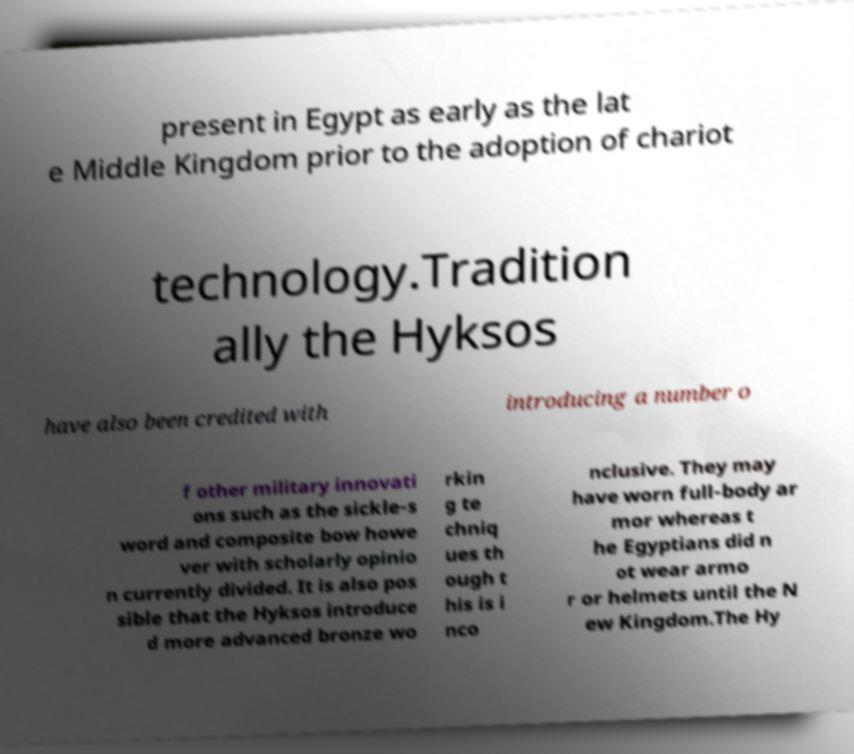I need the written content from this picture converted into text. Can you do that? present in Egypt as early as the lat e Middle Kingdom prior to the adoption of chariot technology.Tradition ally the Hyksos have also been credited with introducing a number o f other military innovati ons such as the sickle-s word and composite bow howe ver with scholarly opinio n currently divided. It is also pos sible that the Hyksos introduce d more advanced bronze wo rkin g te chniq ues th ough t his is i nco nclusive. They may have worn full-body ar mor whereas t he Egyptians did n ot wear armo r or helmets until the N ew Kingdom.The Hy 